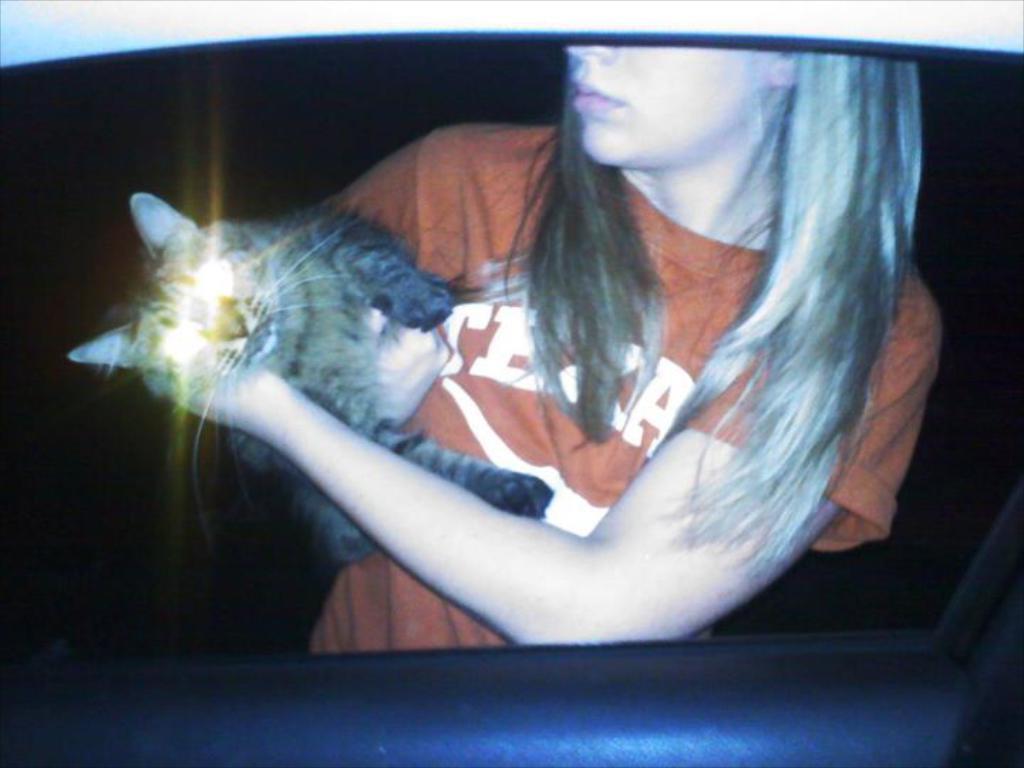Describe this image in one or two sentences. A girl is wearing a t-shirt holding a cat in the dark. 